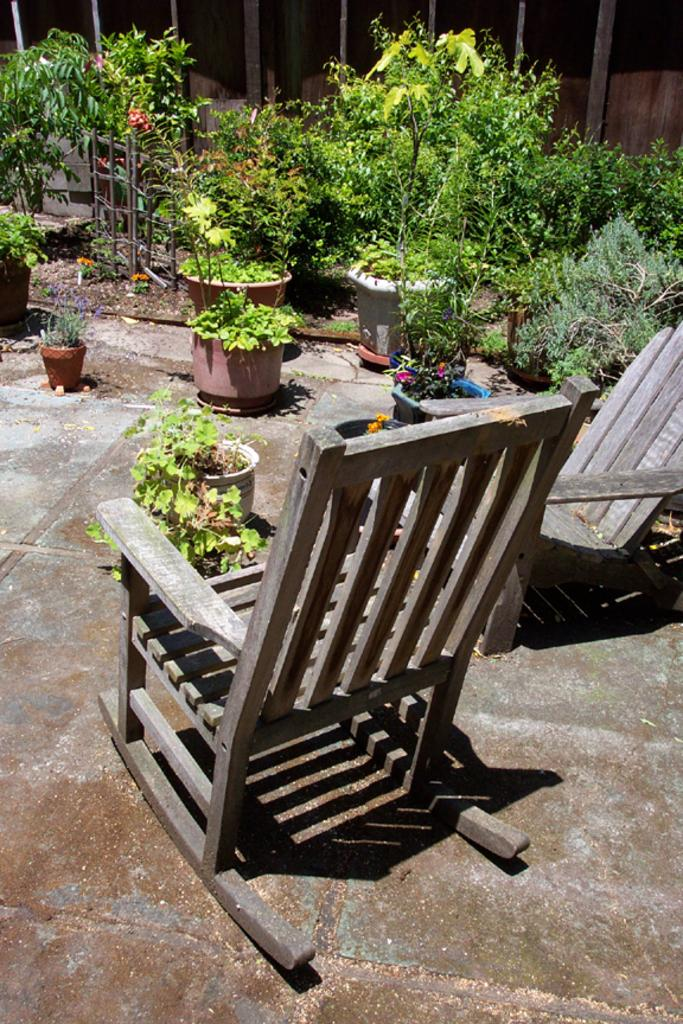How many chairs are visible in the image? There are two chairs in the image. What is placed in front of the chairs? There are plants in pots in front of the chairs. What type of pickle is being used as a decoration on the chairs? There is no pickle present in the image; it features two chairs and plants in pots. 